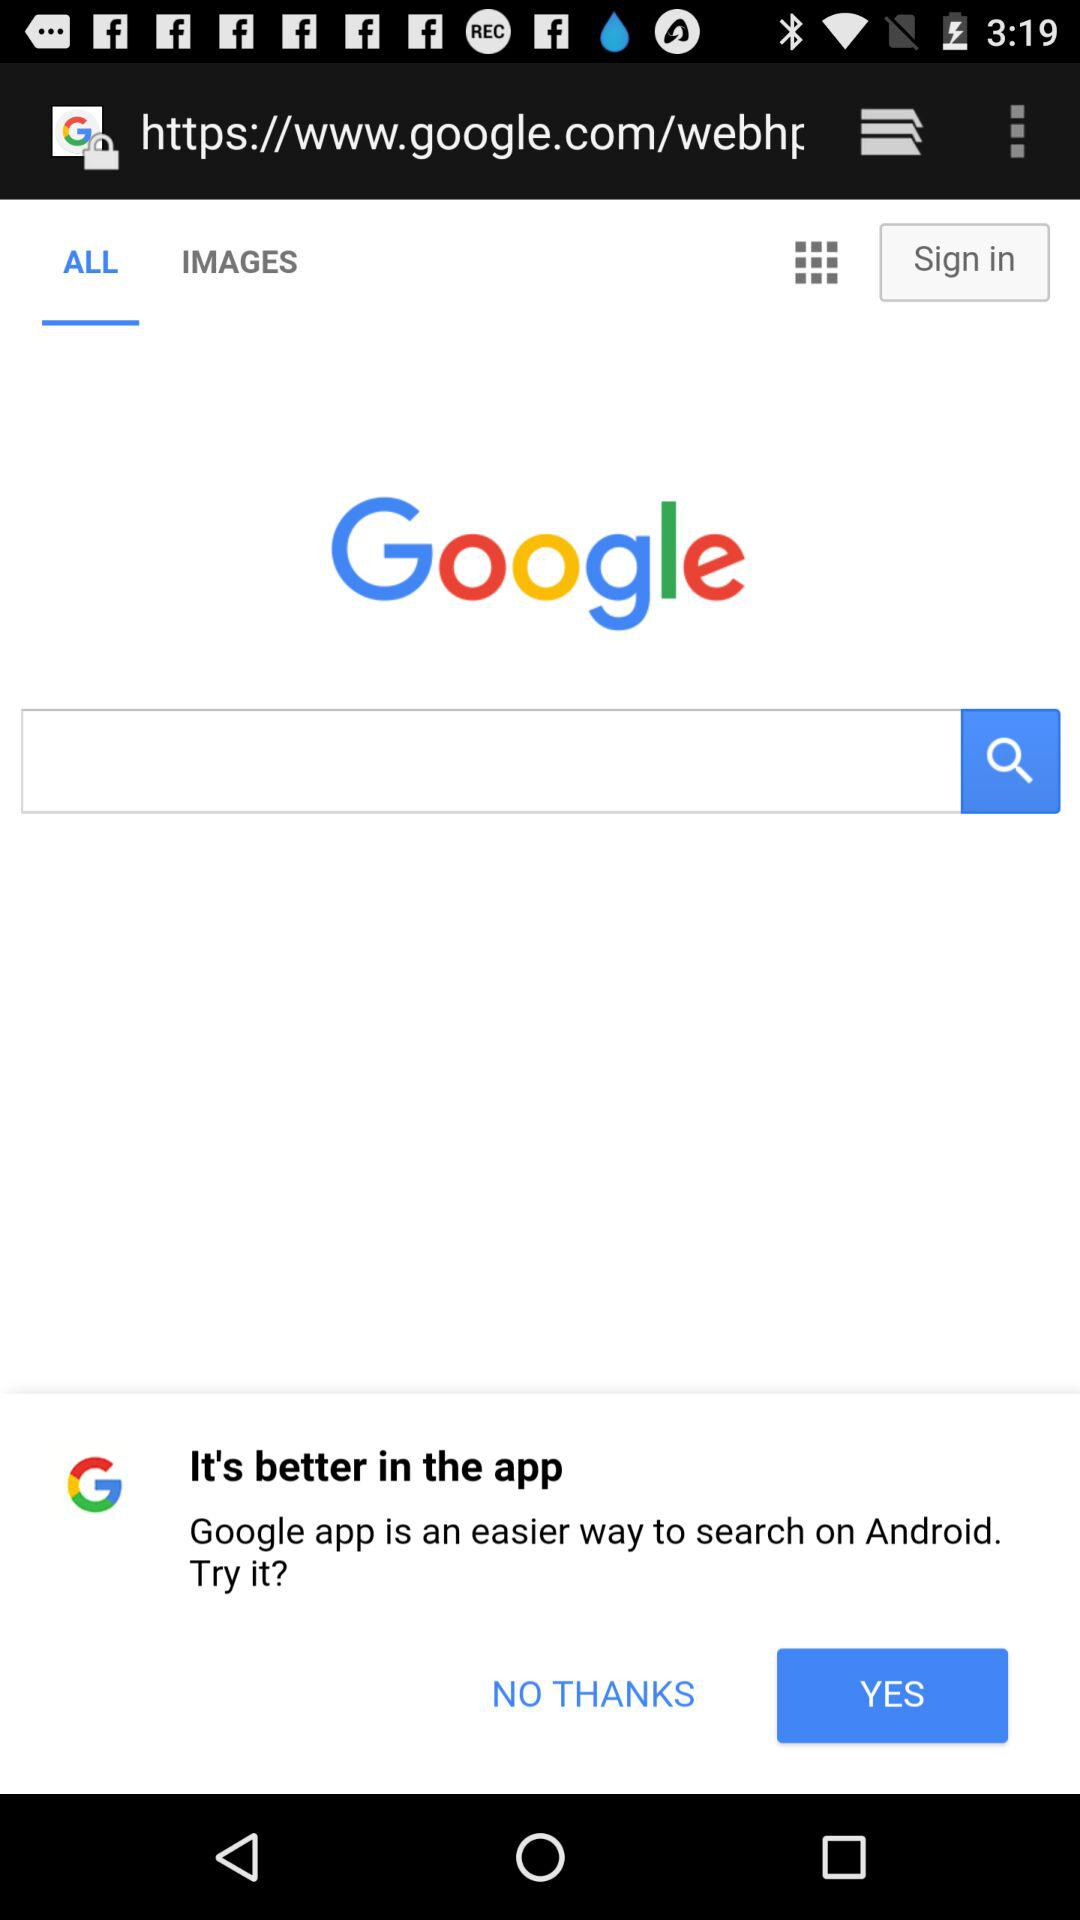What is the application name? The application name is "Google". 